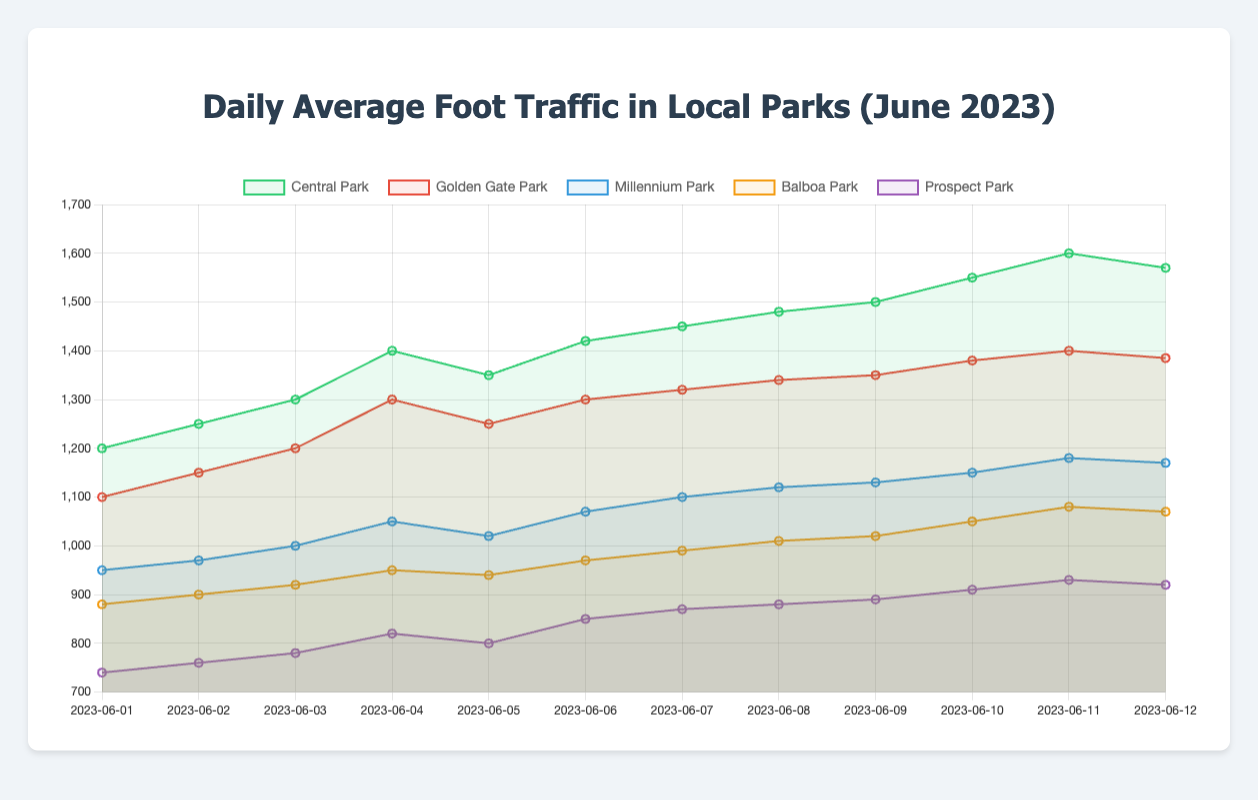Which park had the highest foot traffic on June 7, 2023? Identify the data point for June 7, 2023, and compare the values for all parks. Central Park has 1450, Golden Gate Park has 1320, Millennium Park has 1100, Balboa Park has 990, and Prospect Park has 870. Central Park has the highest value.
Answer: Central Park Which park experienced the smallest increase in foot traffic from June 1 to June 12, 2023? Calculate the difference in foot traffic for each park between June 1 and June 12. Central Park: 1570 - 1200 = 370, Golden Gate Park: 1385 - 1100 = 285, Millennium Park: 1170 - 950 = 220, Balboa Park: 1070 - 880 = 190, Prospect Park: 920 - 740 = 180. Prospect Park has the smallest increase.
Answer: Prospect Park On June 4, 2023, which park had a foot traffic closer to 1000: Millennium Park or Balboa Park? Refer to the data point on June 4, 2023. Millennium Park has 1050 and Balboa Park has 950. The absolute difference from 1000 is 50 for Millennium Park and 50 for Balboa Park. Both are equally close to 1000.
Answer: Both equally close What was the average daily foot traffic in Millennium Park over the entire period? Sum the foot traffic values for Millennium Park over all the days and divide by the number of days (12). (950 + 970 + 1000 + 1050 + 1020 + 1070 + 1100 + 1120 + 1130 + 1150 + 1180 + 1170) / 12 = 11490 / 12 = 957.5
Answer: 957.5 Which days did Balboa Park have higher foot traffic than Prospect Park? Compare the values of Balboa Park and Prospect Park for each day. Balboa Park's foot traffic is higher than Prospect Park on all days: June 1 (880 > 740), June 2 (900 > 760), June 3 (920 > 780), June 4 (950 > 820), June 5 (940 > 800), June 6 (970 > 850), June 7 (990 > 870), June 8 (1010 > 880), June 9 (1020 > 890), June 10 (1050 > 910), June 11 (1080 > 930), and June 12 (1070 > 920).
Answer: All days What was the total foot traffic for Central Park and Golden Gate Park combined on June 10, 2023? Add the foot traffic for Central Park and Golden Gate Park on June 10, 2023. Central Park: 1550, Golden Gate Park: 1380. Total = 1550 + 1380 = 2930.
Answer: 2930 Which park's foot traffic shows the steepest increase from June 6 to June 7, 2023? Calculate the increase in foot traffic for each park from June 6 to June 7. Central Park: 1450 - 1420 = 30, Golden Gate Park: 1320 - 1300 = 20, Millennium Park: 1100 - 1070 = 30, Balboa Park: 990 - 970 = 20, Prospect Park: 870 - 850 = 20. Central Park and Millennium Park both have the steepest increase of 30.
Answer: Central Park & Millennium Park Did any park see a decrease in foot traffic between two consecutive days? If yes, which one and when? Check the foot traffic data for each park for any decrease between consecutive days. Yes, Central Park saw a decrease from June 11 to June 12 (1600 to 1570).
Answer: Central Park, June 11-12 On which date did Golden Gate Park have foot traffic that was closest to the average foot traffic of Balboa Park over the whole period? Calculate the average foot traffic of Balboa Park over the period: (880 + 900 + 920 + 950 + 940 + 970 + 990 + 1010 + 1020 + 1050 + 1080 + 1070) / 12 = 11680 / 12 = 973.3. The closest Golden Gate Park foot traffic is on June 6 with a value of 970.
Answer: June 6 